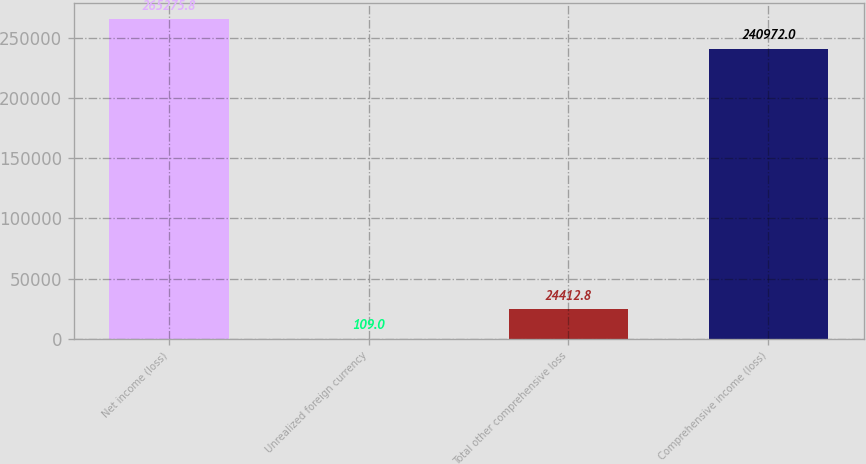Convert chart to OTSL. <chart><loc_0><loc_0><loc_500><loc_500><bar_chart><fcel>Net income (loss)<fcel>Unrealized foreign currency<fcel>Total other comprehensive loss<fcel>Comprehensive income (loss)<nl><fcel>265276<fcel>109<fcel>24412.8<fcel>240972<nl></chart> 